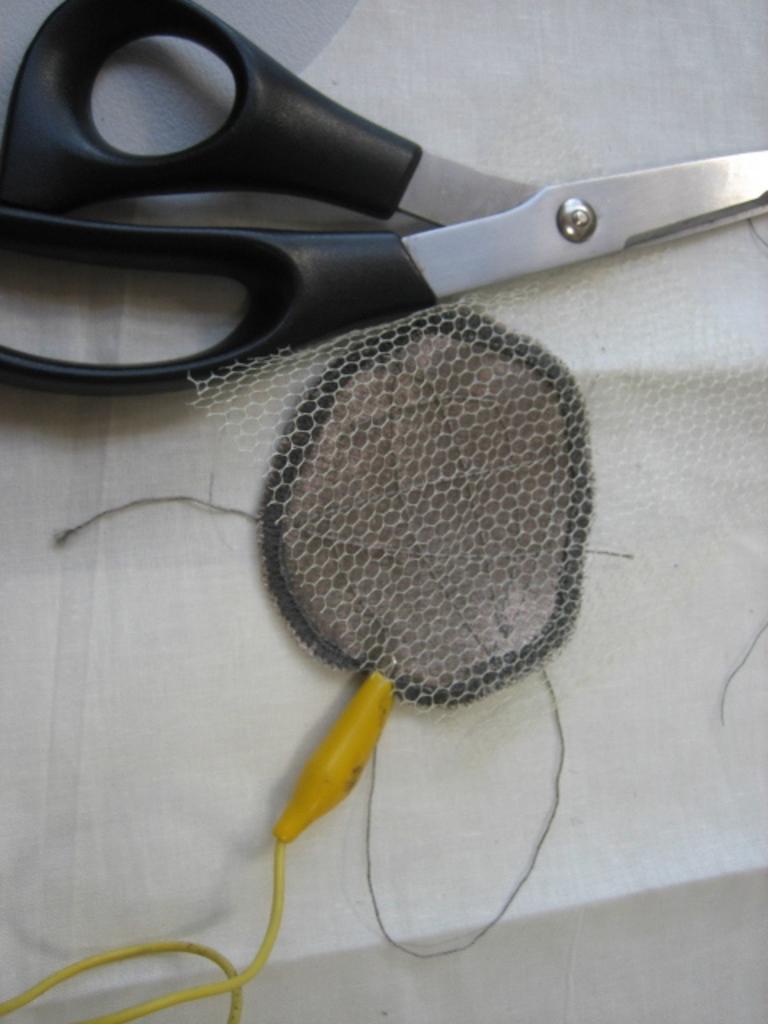Can you describe this image briefly? There is a scissors, net and a yellow color wire on a white surface. 